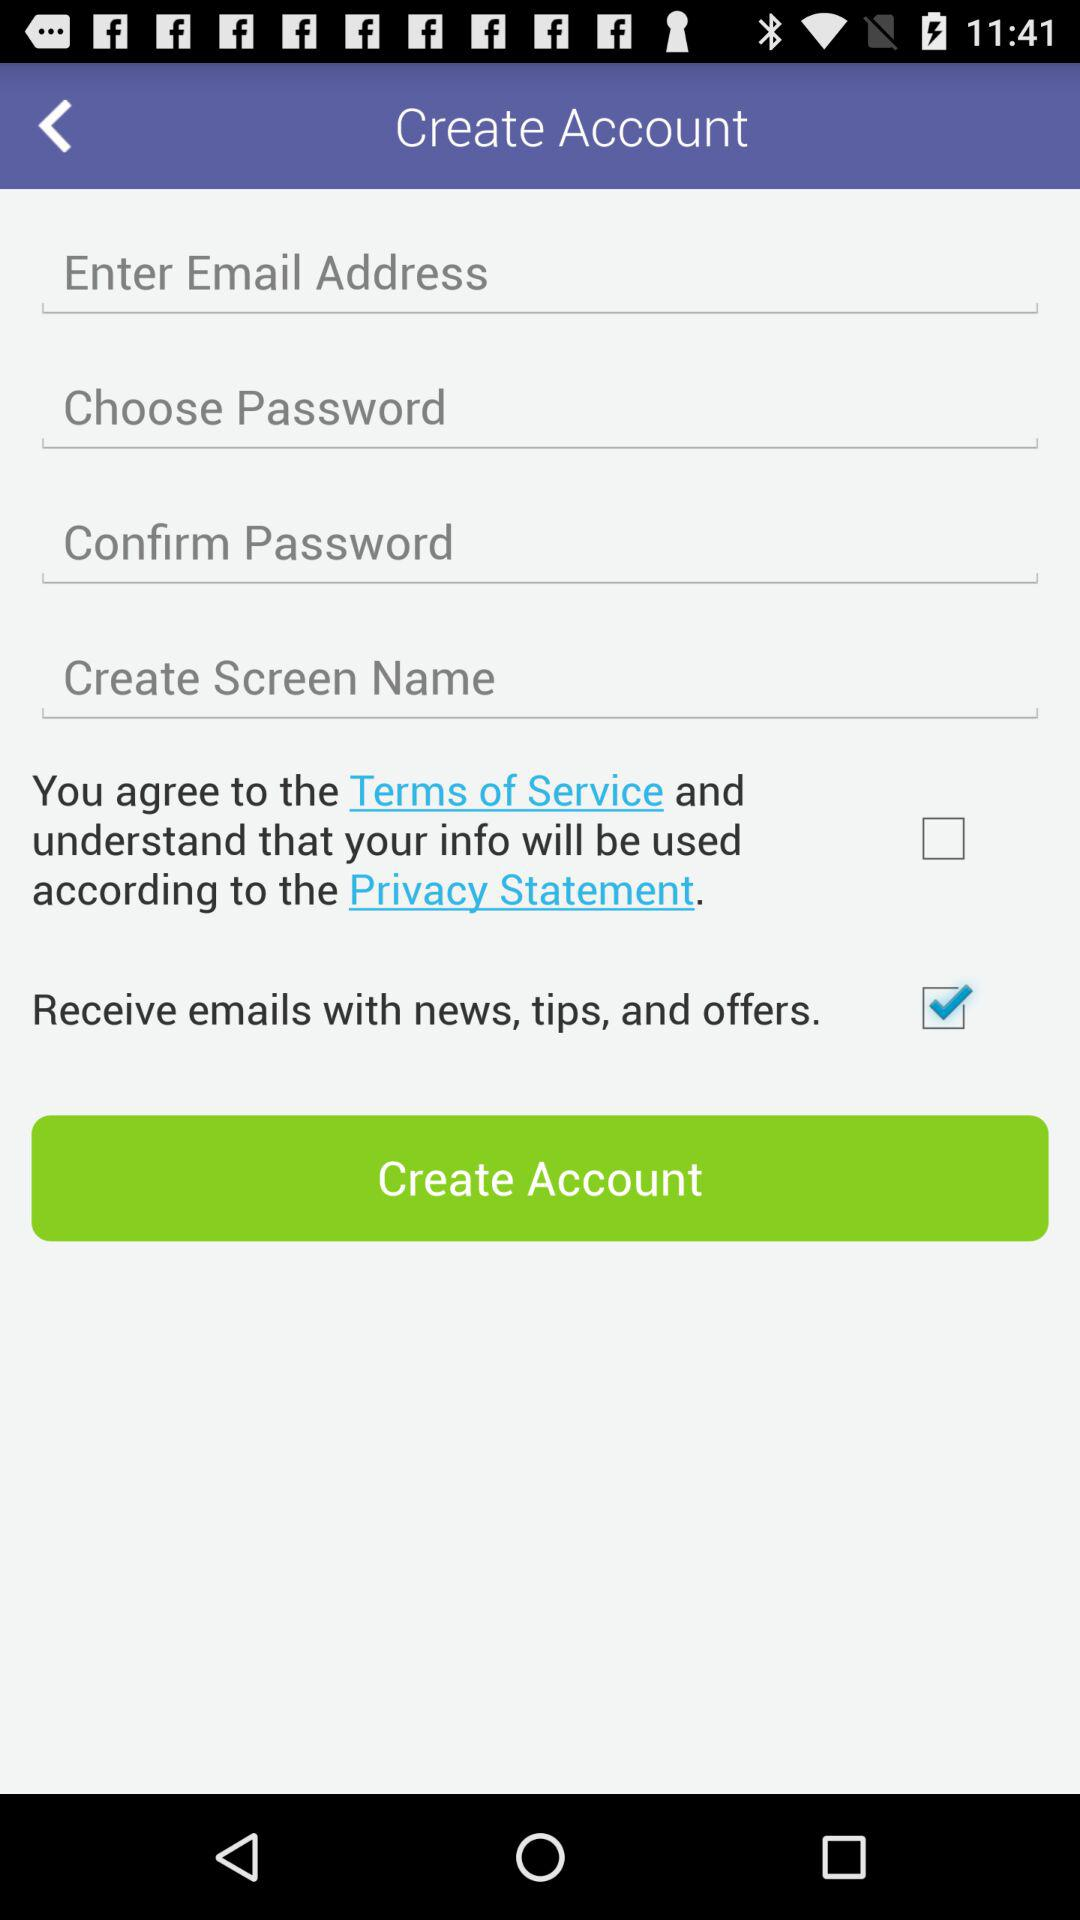Which option was checked? The checked option was "Receive emails with news, tips, and offers". 